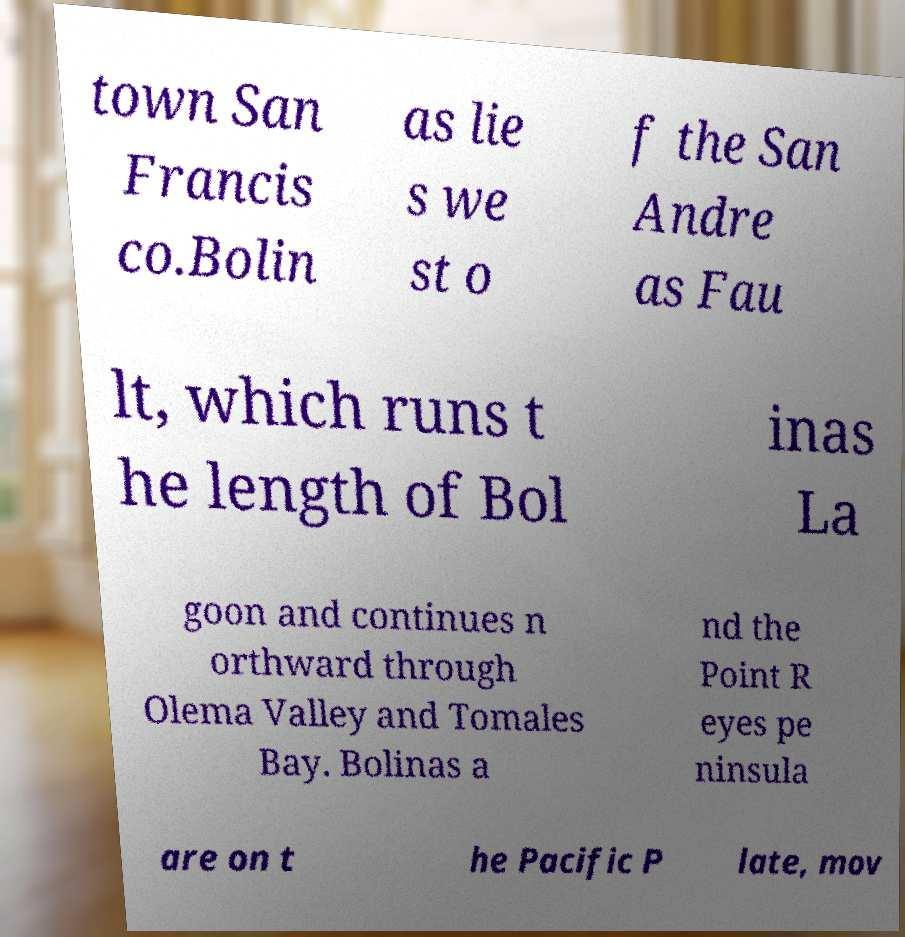I need the written content from this picture converted into text. Can you do that? town San Francis co.Bolin as lie s we st o f the San Andre as Fau lt, which runs t he length of Bol inas La goon and continues n orthward through Olema Valley and Tomales Bay. Bolinas a nd the Point R eyes pe ninsula are on t he Pacific P late, mov 